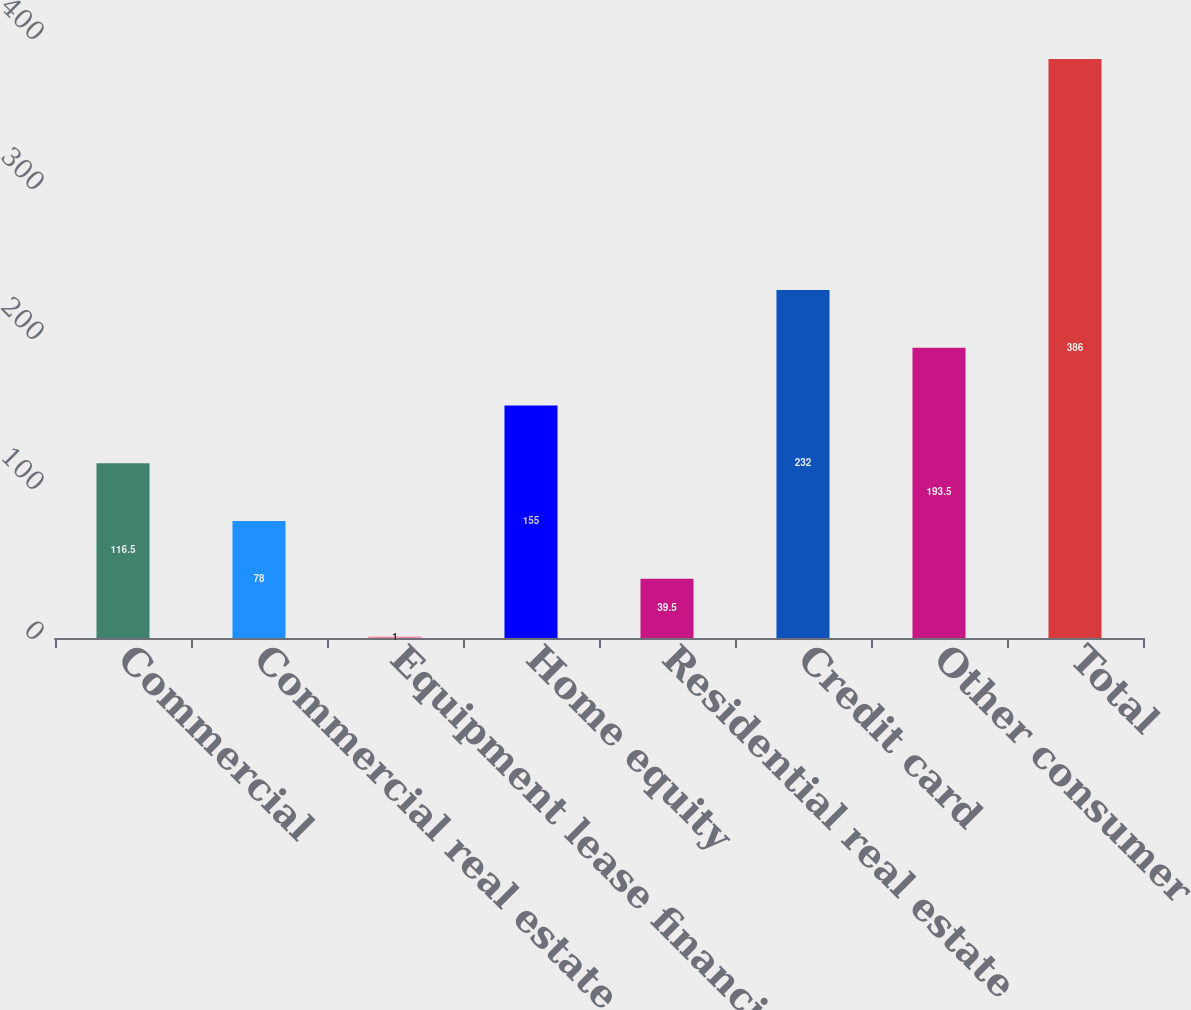Convert chart to OTSL. <chart><loc_0><loc_0><loc_500><loc_500><bar_chart><fcel>Commercial<fcel>Commercial real estate<fcel>Equipment lease financing<fcel>Home equity<fcel>Residential real estate<fcel>Credit card<fcel>Other consumer<fcel>Total<nl><fcel>116.5<fcel>78<fcel>1<fcel>155<fcel>39.5<fcel>232<fcel>193.5<fcel>386<nl></chart> 